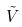<formula> <loc_0><loc_0><loc_500><loc_500>\tilde { V }</formula> 